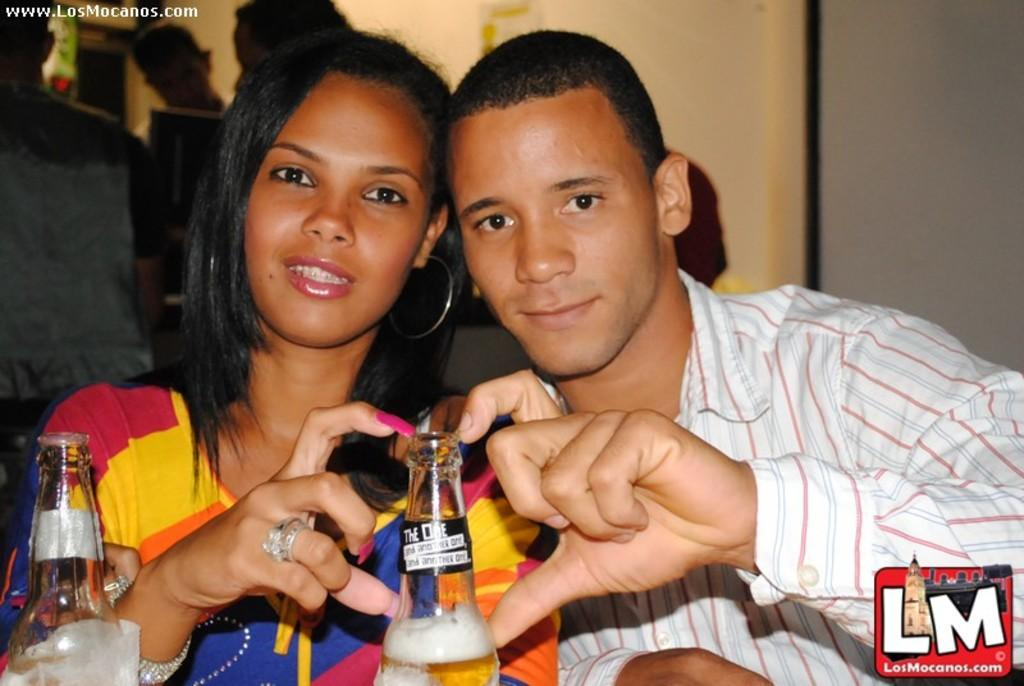How many people are sitting in the image? There are two persons sitting in the image. What can be seen in the background of the image? There is a wall and other persons visible in the background of the image. What objects can be seen in the image besides the people? There are bottles in the image. What type of advertisement can be seen on the feet of the persons in the image? There are no advertisements visible on the feet of the persons in the image, as feet are not mentioned in the provided facts. 